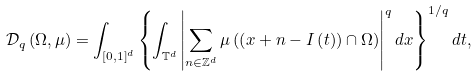<formula> <loc_0><loc_0><loc_500><loc_500>\mathcal { D } _ { q } \left ( \Omega , \mu \right ) = \int _ { \left [ 0 , 1 \right ] ^ { d } } \left \{ \int _ { \mathbb { T } ^ { d } } \left | \sum _ { n \in \mathbb { Z } ^ { d } } \mu \left ( \left ( x + n - I \left ( t \right ) \right ) \cap \Omega \right ) \right | ^ { q } d x \right \} ^ { 1 / q } d t ,</formula> 